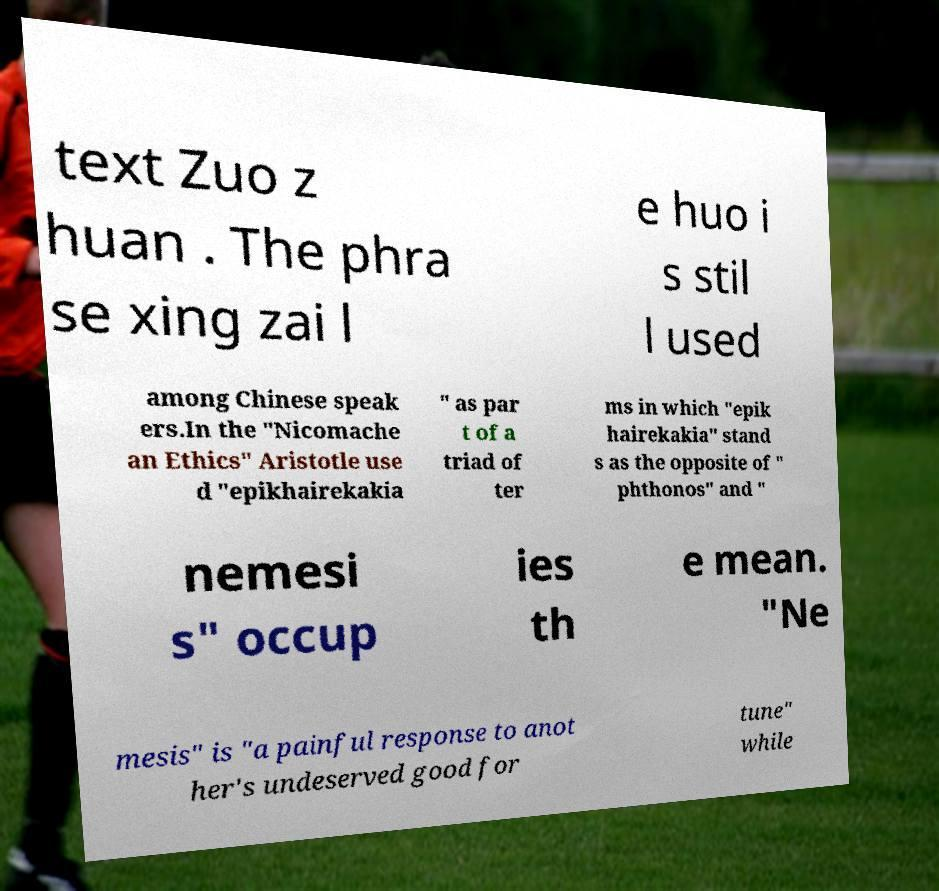Please read and relay the text visible in this image. What does it say? text Zuo z huan . The phra se xing zai l e huo i s stil l used among Chinese speak ers.In the "Nicomache an Ethics" Aristotle use d "epikhairekakia " as par t of a triad of ter ms in which "epik hairekakia" stand s as the opposite of " phthonos" and " nemesi s" occup ies th e mean. "Ne mesis" is "a painful response to anot her's undeserved good for tune" while 